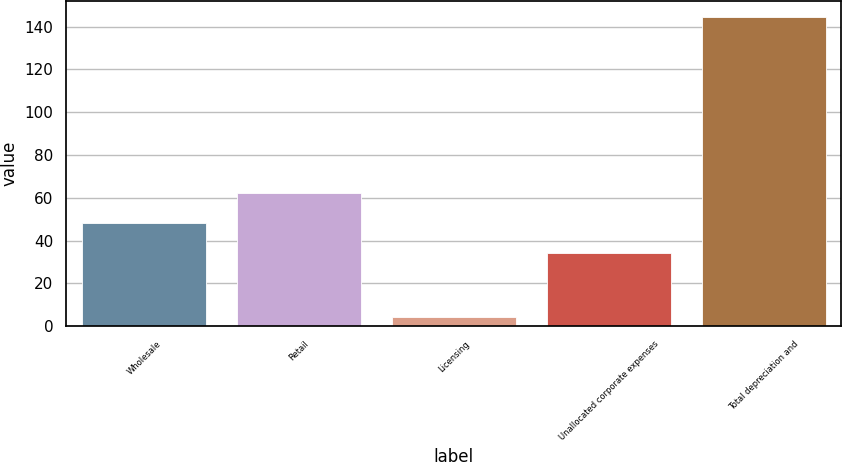Convert chart to OTSL. <chart><loc_0><loc_0><loc_500><loc_500><bar_chart><fcel>Wholesale<fcel>Retail<fcel>Licensing<fcel>Unallocated corporate expenses<fcel>Total depreciation and<nl><fcel>48.33<fcel>62.36<fcel>4.4<fcel>34.3<fcel>144.7<nl></chart> 